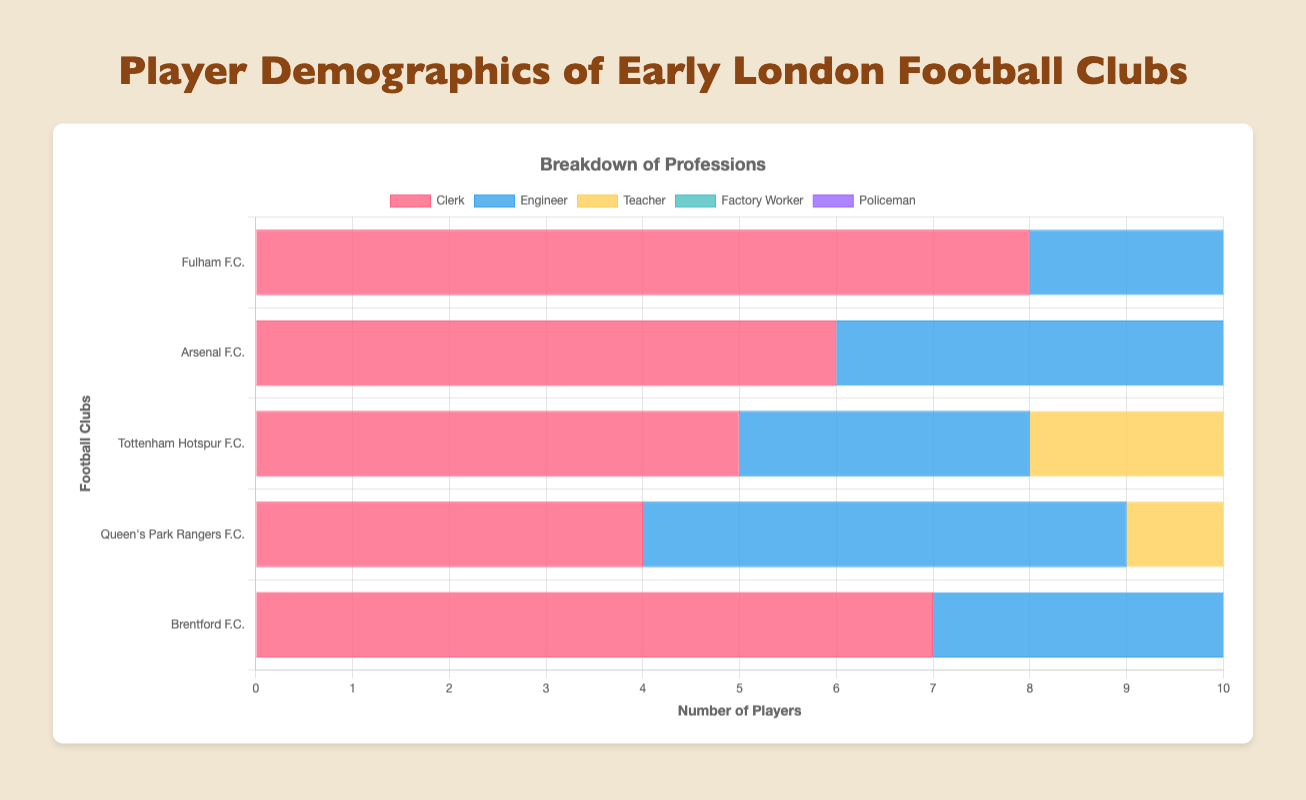Which club has the highest number of engineers? By observing the height of the bars categorized under "Engineer", we can see Arsenal F.C. has the tallest bar, indicating that it has the most engineers.
Answer: Arsenal F.C What is the total number of teachers across all clubs? Sum the numbers of teachers for each club: 3 (Fulham) + 4 (Arsenal) + 4 (Tottenham Hotspur) + 3 (Queen's Park Rangers) + 2 (Brentford) = 16.
Answer: 16 Which profession has the least representation within Arsenal F.C.? By comparing the height of all bars for Arsenal F.C., the "Policeman" bar is the shortest.
Answer: Policeman How many more clerks does Fulham F.C. have than Tottenham Hotspur F.C.? Find the difference between the number of clerks in Fulham (8) and Tottenham Hotspur (5): 8 - 5 = 3.
Answer: 3 Which club has the highest number of players working as Factory Workers? By looking at the bars for "Factory Worker", Tottenham Hotspur F.C. has the tallest bar with 7 factory workers.
Answer: Tottenham Hotspur F.C What's the average number of clerks across all clubs? Sum the clerks' counts (8 + 6 + 5 + 4 + 7) and divide by the number of clubs (5): (8 + 6 + 5 + 4 + 7) / 5 = 6.
Answer: 6 Which profession has the highest representation in Brentford F.C.? By observing the heights of the bars for Brentford, the "Clerk" bar is the highest.
Answer: Clerk Compare the number of engineers in Fulham F.C. and Queen's Park Rangers F.C. Fulham F.C. has 4 engineers, while Queen's Park Rangers F.C. has 5 engineers, so Queen's Park Rangers F.C. has more engineers.
Answer: Queen's Park Rangers F.C What is the total number of players in Brentford F.C.? Sum the counts for all professions within Brentford F.C.: 7 (Clerk) + 4 (Engineer) + 2 (Teacher) + 5 (Factory Worker) + 1 (Policeman) = 19.
Answer: 19 Which profession has a consistent number of 4 players across two or more clubs? By looking at the bars across all clubs, both Arsenal and Brentford have 4 engineers, and Tottenham Hotspur and Arsenal have 4 teachers. Therefore, Engineer appears more predominantly.
Answer: Engineer 